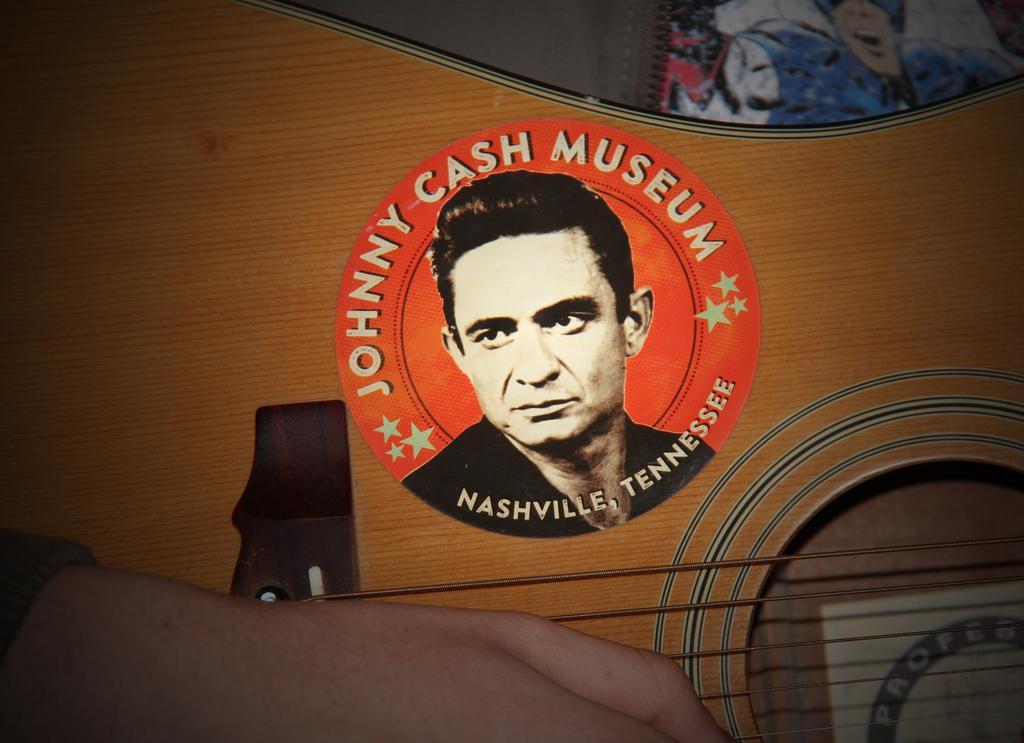In one or two sentences, can you explain what this image depicts? In this picture we can see the hand of a person. There is some text, images of the stars and a person on this guitar. We can see a colorful object in the top right. 